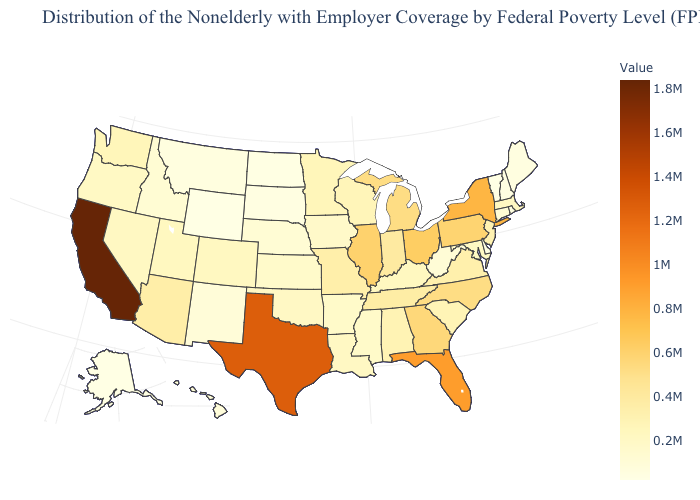Among the states that border Vermont , does New Hampshire have the lowest value?
Concise answer only. Yes. Does California have the highest value in the USA?
Give a very brief answer. Yes. Does California have the highest value in the USA?
Short answer required. Yes. Does Ohio have a lower value than Alaska?
Keep it brief. No. Is the legend a continuous bar?
Be succinct. Yes. Is the legend a continuous bar?
Quick response, please. Yes. Does North Carolina have a lower value than New Mexico?
Give a very brief answer. No. 